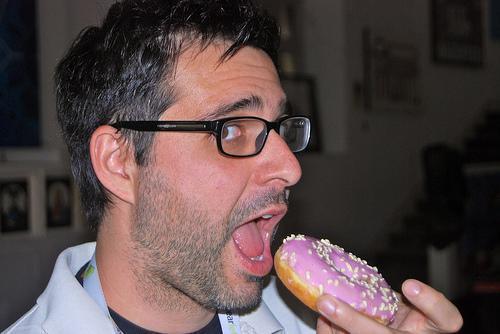How many glasses are shown?
Give a very brief answer. 1. How many people can be seen?
Give a very brief answer. 1. How many donuts are in the photo?
Give a very brief answer. 1. 